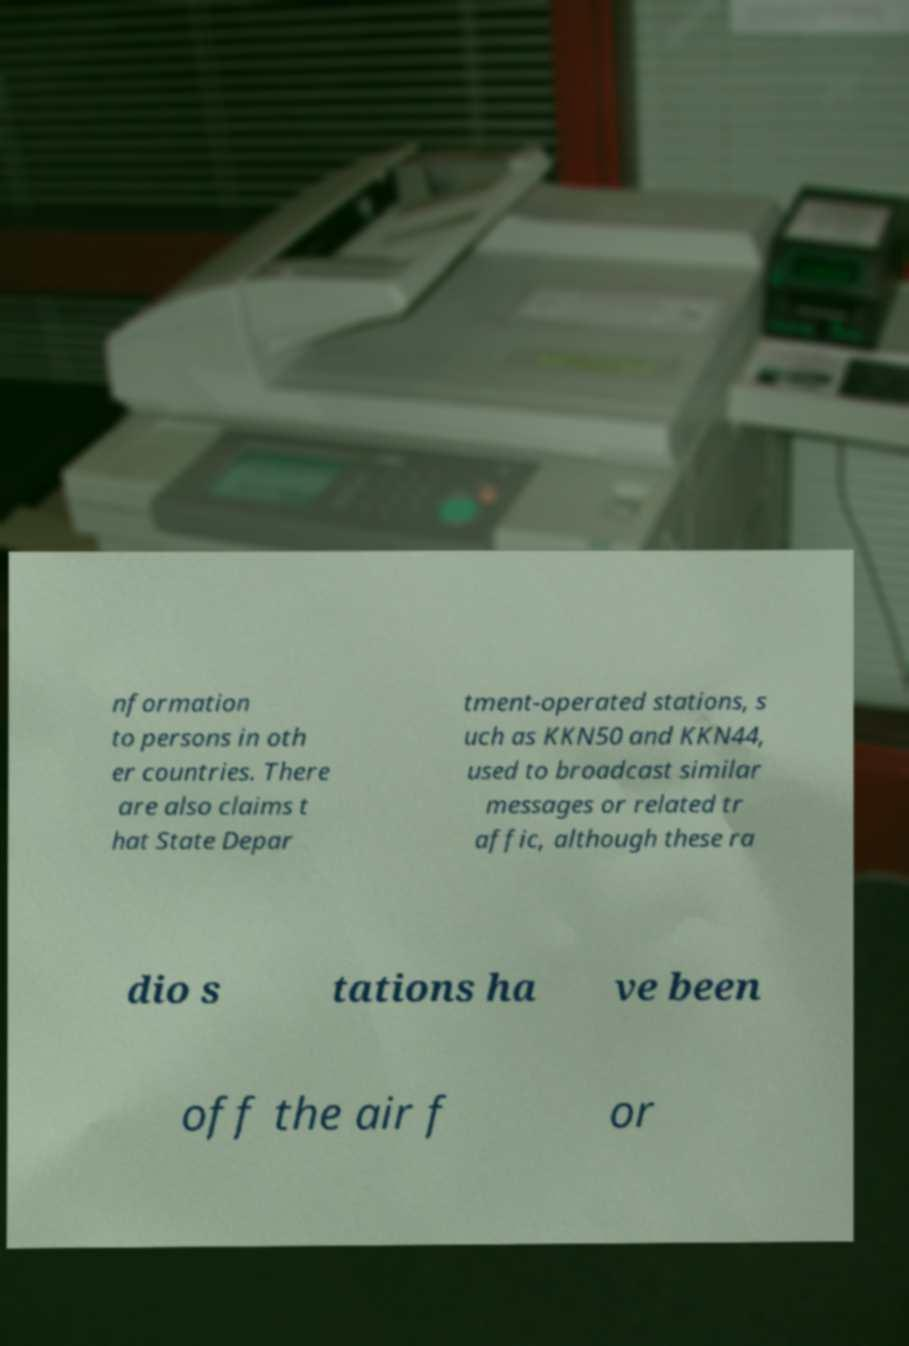Please identify and transcribe the text found in this image. nformation to persons in oth er countries. There are also claims t hat State Depar tment-operated stations, s uch as KKN50 and KKN44, used to broadcast similar messages or related tr affic, although these ra dio s tations ha ve been off the air f or 